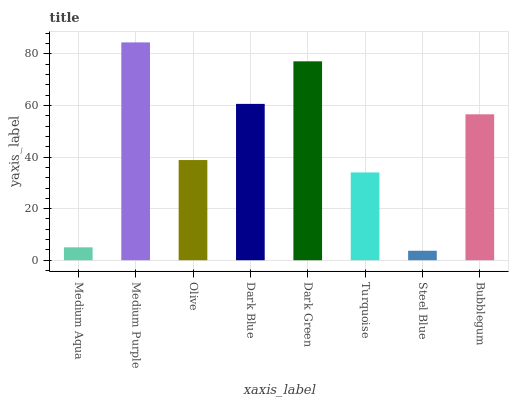Is Steel Blue the minimum?
Answer yes or no. Yes. Is Medium Purple the maximum?
Answer yes or no. Yes. Is Olive the minimum?
Answer yes or no. No. Is Olive the maximum?
Answer yes or no. No. Is Medium Purple greater than Olive?
Answer yes or no. Yes. Is Olive less than Medium Purple?
Answer yes or no. Yes. Is Olive greater than Medium Purple?
Answer yes or no. No. Is Medium Purple less than Olive?
Answer yes or no. No. Is Bubblegum the high median?
Answer yes or no. Yes. Is Olive the low median?
Answer yes or no. Yes. Is Olive the high median?
Answer yes or no. No. Is Dark Green the low median?
Answer yes or no. No. 